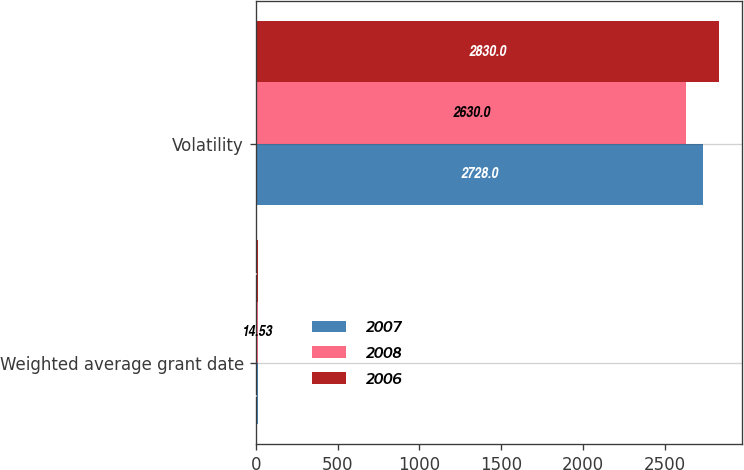<chart> <loc_0><loc_0><loc_500><loc_500><stacked_bar_chart><ecel><fcel>Weighted average grant date<fcel>Volatility<nl><fcel>2007<fcel>12.87<fcel>2728<nl><fcel>2008<fcel>14.53<fcel>2630<nl><fcel>2006<fcel>12.75<fcel>2830<nl></chart> 